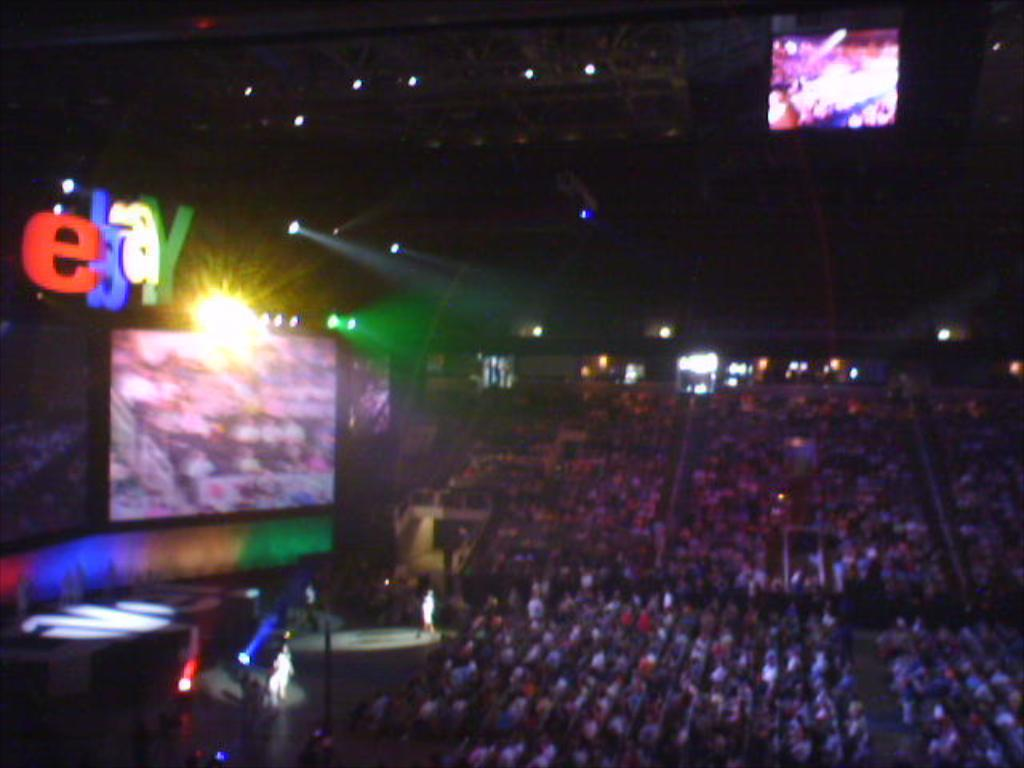<image>
Share a concise interpretation of the image provided. an arena filled with people with a big monitor and EBAY over it 